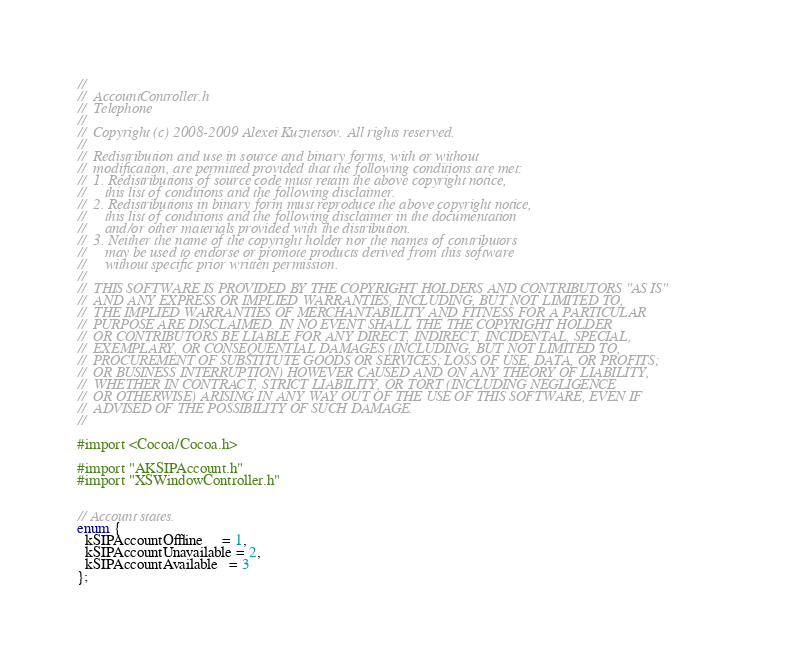<code> <loc_0><loc_0><loc_500><loc_500><_C_>//
//  AccountController.h
//  Telephone
//
//  Copyright (c) 2008-2009 Alexei Kuznetsov. All rights reserved.
//
//  Redistribution and use in source and binary forms, with or without
//  modification, are permitted provided that the following conditions are met:
//  1. Redistributions of source code must retain the above copyright notice,
//     this list of conditions and the following disclaimer.
//  2. Redistributions in binary form must reproduce the above copyright notice,
//     this list of conditions and the following disclaimer in the documentation
//     and/or other materials provided with the distribution.
//  3. Neither the name of the copyright holder nor the names of contributors
//     may be used to endorse or promote products derived from this software
//     without specific prior written permission.
//
//  THIS SOFTWARE IS PROVIDED BY THE COPYRIGHT HOLDERS AND CONTRIBUTORS "AS IS"
//  AND ANY EXPRESS OR IMPLIED WARRANTIES, INCLUDING, BUT NOT LIMITED TO,
//  THE IMPLIED WARRANTIES OF MERCHANTABILITY AND FITNESS FOR A PARTICULAR
//  PURPOSE ARE DISCLAIMED. IN NO EVENT SHALL THE THE COPYRIGHT HOLDER
//  OR CONTRIBUTORS BE LIABLE FOR ANY DIRECT, INDIRECT, INCIDENTAL, SPECIAL,
//  EXEMPLARY, OR CONSEQUENTIAL DAMAGES (INCLUDING, BUT NOT LIMITED TO,
//  PROCUREMENT OF SUBSTITUTE GOODS OR SERVICES; LOSS OF USE, DATA, OR PROFITS;
//  OR BUSINESS INTERRUPTION) HOWEVER CAUSED AND ON ANY THEORY OF LIABILITY,
//  WHETHER IN CONTRACT, STRICT LIABILITY, OR TORT (INCLUDING NEGLIGENCE
//  OR OTHERWISE) ARISING IN ANY WAY OUT OF THE USE OF THIS SOFTWARE, EVEN IF
//  ADVISED OF THE POSSIBILITY OF SUCH DAMAGE.
//

#import <Cocoa/Cocoa.h>

#import "AKSIPAccount.h"
#import "XSWindowController.h"


// Account states.
enum {
  kSIPAccountOffline     = 1,
  kSIPAccountUnavailable = 2,
  kSIPAccountAvailable   = 3
};
</code> 